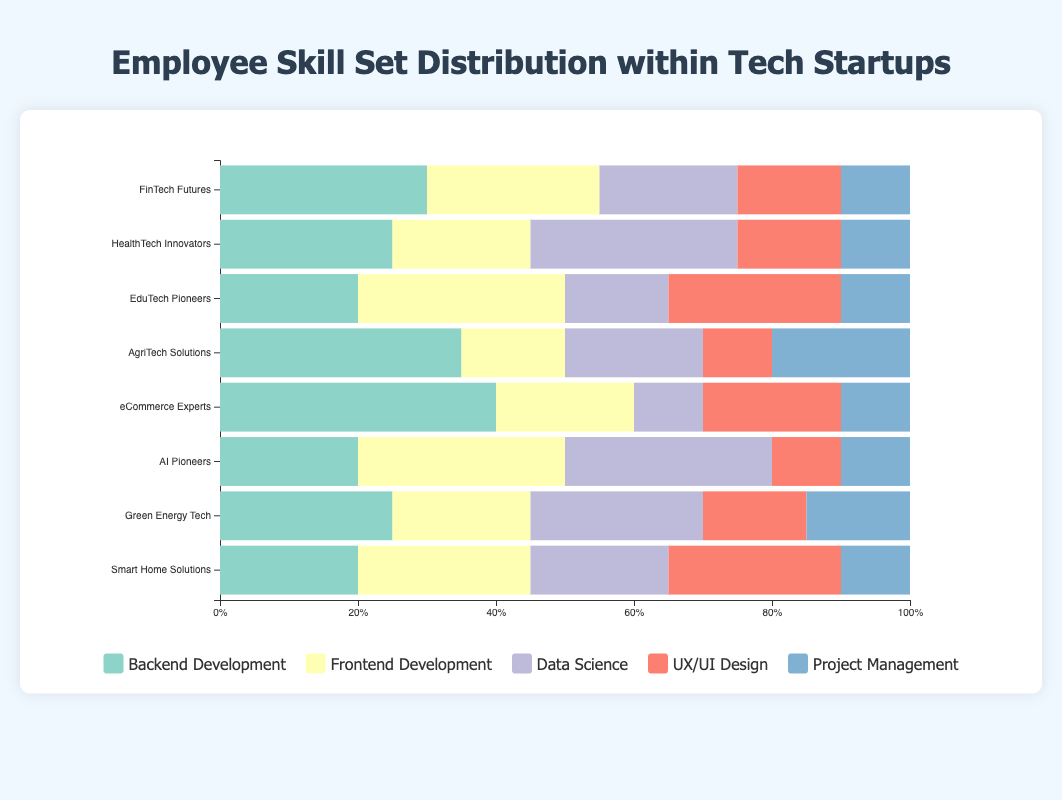What is the total percentage of employees specializing in Backend Development across all companies? Sum the percentages of Backend Development for all companies: 30% (FinTech Futures) + 25% (HealthTech Innovators) + 20% (EduTech Pioneers) + 35% (AgriTech Solutions) + 40% (eCommerce Experts) + 20% (AI Pioneers) + 25% (Green Energy Tech) + 20% (Smart Home Solutions). Thus, 30 + 25 + 20 + 35 + 40 + 20 + 25 + 20 = 215.
Answer: 215% Which company has the highest percentage of employees in Backend Development? Find and compare the Backend Development percentages for all companies. The highest percentage is 40% from eCommerce Experts.
Answer: eCommerce Experts What is the combined percentage of employees in Data Science and UX/UI Design at HealthTech Innovators? Add the percentages of Data Science (30%) and UX/UI Design (15%) at HealthTech Innovators: 30 + 15 = 45.
Answer: 45% Which company has an equal percentage of employees in Backend Development and Frontend Development? Check for which companies the percentages of Backend Development and Frontend Development are equal. No company has equal percentages in these categories.
Answer: None Which company has the most diverse skill set distribution, considering the skills with the least difference in percentages? Compare the spread of skill set percentages for each company: "EduTech Pioneers" has close percentages across various skills (20%, 30%, 15%, 25%, 10%), with the least difference, indicating a more balanced distribution.
Answer: EduTech Pioneers What is the percentage difference in UX/UI Design skills between eCommerce Experts and Smart Home Solutions? Calculate the absolute difference: eCommerce Experts (20%) - Smart Home Solutions (25%) = -5%, which gives a difference of 5%.
Answer: 5% What is the average percentage of employees in Project Management across all companies? Calculate the average by summing up Project Management percentages and then dividing by the number of companies: (10 + 10 + 10 + 20 + 10 + 10 + 15 + 10) / 8 = 95 / 8 = 11.875.
Answer: 11.875% Between FinTech Futures and AgriTech Solutions, which company has a higher percentage of employees in Data Science and by how much? Subtract the Data Science percentage at FinTech Futures (20%) from AgriTech Solutions (20%): 20 - 20 = 0. So, both companies have an equal percentage of employees in Data Science.
Answer: 0% How many companies have a higher percentage of employees in Frontend Development than Backend Development? Compare Frontend Development to Backend Development percentages for all companies: HealthTech Innovators (No), EduTech Pioneers (Yes), AgriTech Solutions (No), eCommerce Experts (No), AI Pioneers (Yes), Green Energy Tech (No), Smart Home Solutions (Yes). The count is 3 companies.
Answer: 3 Which skill has the least representation at FinTech Futures? Identify the skill with the smallest percentage at FinTech Futures, which is Project Management (10%).
Answer: Project Management 